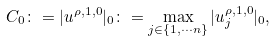<formula> <loc_0><loc_0><loc_500><loc_500>C _ { 0 } \colon = | { u } ^ { \rho , 1 , 0 } | _ { 0 } \colon = \max _ { j \in \left \{ 1 , \cdots n \right \} } | u ^ { \rho , 1 , 0 } _ { j } | _ { 0 } ,</formula> 